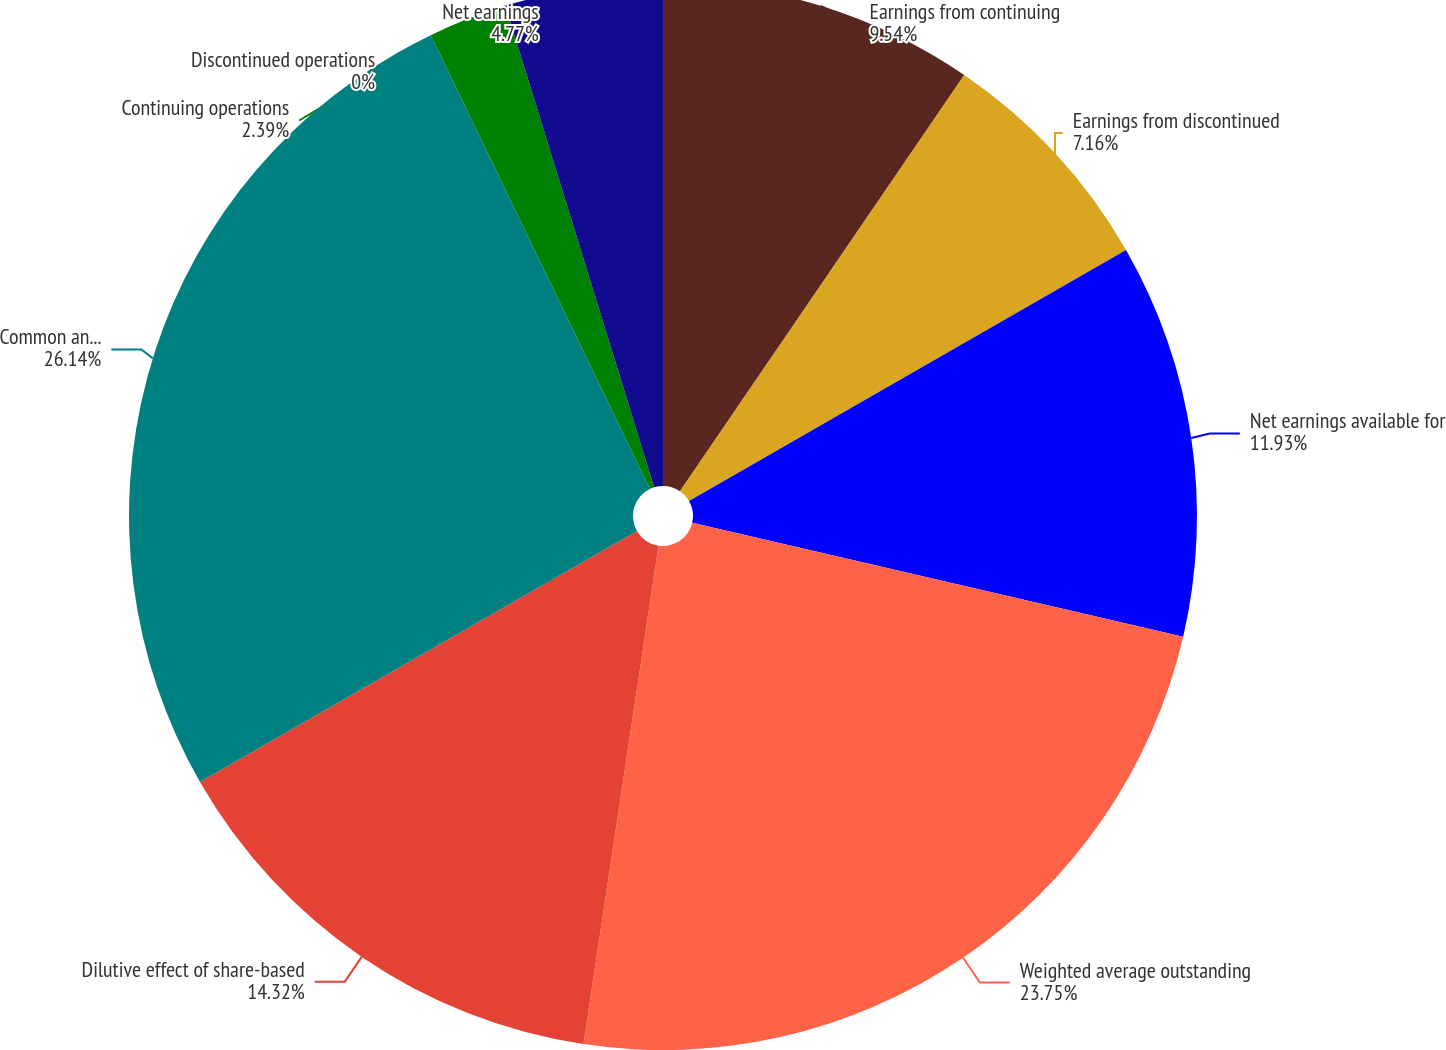Convert chart. <chart><loc_0><loc_0><loc_500><loc_500><pie_chart><fcel>Earnings from continuing<fcel>Earnings from discontinued<fcel>Net earnings available for<fcel>Weighted average outstanding<fcel>Dilutive effect of share-based<fcel>Common and exchangeable stock<fcel>Continuing operations<fcel>Discontinued operations<fcel>Net earnings<nl><fcel>9.54%<fcel>7.16%<fcel>11.93%<fcel>23.75%<fcel>14.32%<fcel>26.14%<fcel>2.39%<fcel>0.0%<fcel>4.77%<nl></chart> 